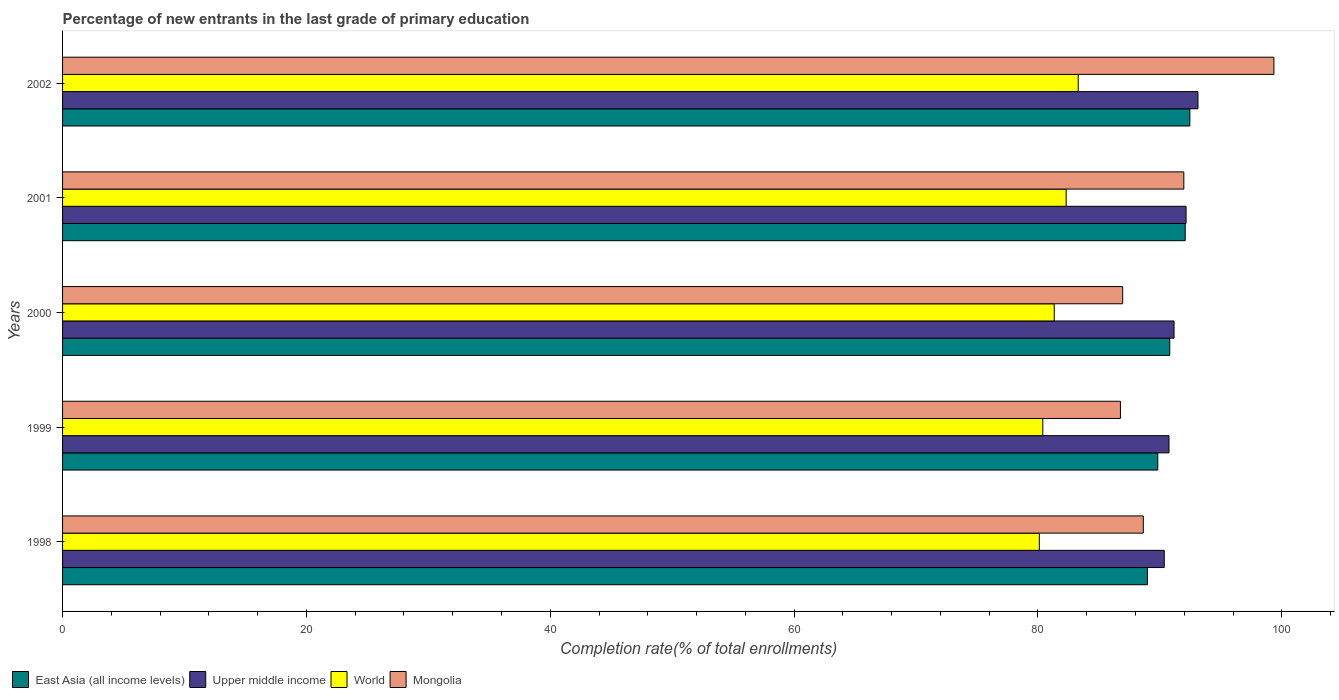How many different coloured bars are there?
Ensure brevity in your answer.  4. How many groups of bars are there?
Make the answer very short. 5. Are the number of bars on each tick of the Y-axis equal?
Your response must be concise. Yes. How many bars are there on the 4th tick from the bottom?
Your answer should be compact. 4. What is the percentage of new entrants in East Asia (all income levels) in 2000?
Provide a short and direct response. 90.81. Across all years, what is the maximum percentage of new entrants in World?
Offer a very short reply. 83.3. Across all years, what is the minimum percentage of new entrants in Mongolia?
Offer a very short reply. 86.76. What is the total percentage of new entrants in East Asia (all income levels) in the graph?
Offer a very short reply. 454.14. What is the difference between the percentage of new entrants in East Asia (all income levels) in 1998 and that in 2000?
Your response must be concise. -1.83. What is the difference between the percentage of new entrants in East Asia (all income levels) in 1998 and the percentage of new entrants in World in 2001?
Provide a succinct answer. 6.66. What is the average percentage of new entrants in Upper middle income per year?
Offer a terse response. 91.5. In the year 2001, what is the difference between the percentage of new entrants in Mongolia and percentage of new entrants in World?
Keep it short and to the point. 9.65. What is the ratio of the percentage of new entrants in Upper middle income in 1998 to that in 2001?
Provide a succinct answer. 0.98. Is the percentage of new entrants in World in 1998 less than that in 1999?
Offer a terse response. Yes. Is the difference between the percentage of new entrants in Mongolia in 2001 and 2002 greater than the difference between the percentage of new entrants in World in 2001 and 2002?
Your answer should be compact. No. What is the difference between the highest and the second highest percentage of new entrants in Mongolia?
Offer a terse response. 7.39. What is the difference between the highest and the lowest percentage of new entrants in East Asia (all income levels)?
Give a very brief answer. 3.48. In how many years, is the percentage of new entrants in Upper middle income greater than the average percentage of new entrants in Upper middle income taken over all years?
Provide a succinct answer. 2. Is the sum of the percentage of new entrants in East Asia (all income levels) in 2001 and 2002 greater than the maximum percentage of new entrants in Mongolia across all years?
Your answer should be compact. Yes. What does the 1st bar from the top in 2000 represents?
Make the answer very short. Mongolia. What does the 1st bar from the bottom in 1998 represents?
Offer a very short reply. East Asia (all income levels). Is it the case that in every year, the sum of the percentage of new entrants in Mongolia and percentage of new entrants in East Asia (all income levels) is greater than the percentage of new entrants in Upper middle income?
Offer a terse response. Yes. How many bars are there?
Keep it short and to the point. 20. How many years are there in the graph?
Make the answer very short. 5. What is the difference between two consecutive major ticks on the X-axis?
Give a very brief answer. 20. Does the graph contain any zero values?
Ensure brevity in your answer.  No. Does the graph contain grids?
Your answer should be compact. No. How are the legend labels stacked?
Offer a very short reply. Horizontal. What is the title of the graph?
Make the answer very short. Percentage of new entrants in the last grade of primary education. What is the label or title of the X-axis?
Offer a very short reply. Completion rate(% of total enrollments). What is the Completion rate(% of total enrollments) in East Asia (all income levels) in 1998?
Provide a succinct answer. 88.97. What is the Completion rate(% of total enrollments) of Upper middle income in 1998?
Provide a succinct answer. 90.36. What is the Completion rate(% of total enrollments) in World in 1998?
Provide a short and direct response. 80.11. What is the Completion rate(% of total enrollments) of Mongolia in 1998?
Offer a terse response. 88.64. What is the Completion rate(% of total enrollments) of East Asia (all income levels) in 1999?
Make the answer very short. 89.83. What is the Completion rate(% of total enrollments) of Upper middle income in 1999?
Make the answer very short. 90.74. What is the Completion rate(% of total enrollments) of World in 1999?
Provide a succinct answer. 80.39. What is the Completion rate(% of total enrollments) of Mongolia in 1999?
Keep it short and to the point. 86.76. What is the Completion rate(% of total enrollments) in East Asia (all income levels) in 2000?
Make the answer very short. 90.81. What is the Completion rate(% of total enrollments) of Upper middle income in 2000?
Your answer should be compact. 91.16. What is the Completion rate(% of total enrollments) of World in 2000?
Your answer should be compact. 81.33. What is the Completion rate(% of total enrollments) of Mongolia in 2000?
Give a very brief answer. 86.95. What is the Completion rate(% of total enrollments) in East Asia (all income levels) in 2001?
Your response must be concise. 92.08. What is the Completion rate(% of total enrollments) of Upper middle income in 2001?
Give a very brief answer. 92.14. What is the Completion rate(% of total enrollments) of World in 2001?
Provide a short and direct response. 82.31. What is the Completion rate(% of total enrollments) in Mongolia in 2001?
Your answer should be very brief. 91.96. What is the Completion rate(% of total enrollments) in East Asia (all income levels) in 2002?
Keep it short and to the point. 92.46. What is the Completion rate(% of total enrollments) of Upper middle income in 2002?
Your answer should be very brief. 93.12. What is the Completion rate(% of total enrollments) of World in 2002?
Keep it short and to the point. 83.3. What is the Completion rate(% of total enrollments) in Mongolia in 2002?
Offer a terse response. 99.35. Across all years, what is the maximum Completion rate(% of total enrollments) in East Asia (all income levels)?
Your answer should be very brief. 92.46. Across all years, what is the maximum Completion rate(% of total enrollments) in Upper middle income?
Offer a very short reply. 93.12. Across all years, what is the maximum Completion rate(% of total enrollments) of World?
Provide a short and direct response. 83.3. Across all years, what is the maximum Completion rate(% of total enrollments) of Mongolia?
Offer a very short reply. 99.35. Across all years, what is the minimum Completion rate(% of total enrollments) of East Asia (all income levels)?
Make the answer very short. 88.97. Across all years, what is the minimum Completion rate(% of total enrollments) of Upper middle income?
Give a very brief answer. 90.36. Across all years, what is the minimum Completion rate(% of total enrollments) in World?
Give a very brief answer. 80.11. Across all years, what is the minimum Completion rate(% of total enrollments) in Mongolia?
Keep it short and to the point. 86.76. What is the total Completion rate(% of total enrollments) in East Asia (all income levels) in the graph?
Offer a very short reply. 454.14. What is the total Completion rate(% of total enrollments) of Upper middle income in the graph?
Offer a very short reply. 457.52. What is the total Completion rate(% of total enrollments) of World in the graph?
Your response must be concise. 407.44. What is the total Completion rate(% of total enrollments) in Mongolia in the graph?
Your response must be concise. 453.66. What is the difference between the Completion rate(% of total enrollments) of East Asia (all income levels) in 1998 and that in 1999?
Your answer should be very brief. -0.85. What is the difference between the Completion rate(% of total enrollments) in Upper middle income in 1998 and that in 1999?
Give a very brief answer. -0.39. What is the difference between the Completion rate(% of total enrollments) in World in 1998 and that in 1999?
Keep it short and to the point. -0.28. What is the difference between the Completion rate(% of total enrollments) in Mongolia in 1998 and that in 1999?
Your answer should be very brief. 1.88. What is the difference between the Completion rate(% of total enrollments) of East Asia (all income levels) in 1998 and that in 2000?
Ensure brevity in your answer.  -1.83. What is the difference between the Completion rate(% of total enrollments) in Upper middle income in 1998 and that in 2000?
Offer a terse response. -0.8. What is the difference between the Completion rate(% of total enrollments) of World in 1998 and that in 2000?
Ensure brevity in your answer.  -1.22. What is the difference between the Completion rate(% of total enrollments) of Mongolia in 1998 and that in 2000?
Give a very brief answer. 1.69. What is the difference between the Completion rate(% of total enrollments) of East Asia (all income levels) in 1998 and that in 2001?
Ensure brevity in your answer.  -3.1. What is the difference between the Completion rate(% of total enrollments) in Upper middle income in 1998 and that in 2001?
Make the answer very short. -1.79. What is the difference between the Completion rate(% of total enrollments) of World in 1998 and that in 2001?
Your response must be concise. -2.2. What is the difference between the Completion rate(% of total enrollments) in Mongolia in 1998 and that in 2001?
Ensure brevity in your answer.  -3.32. What is the difference between the Completion rate(% of total enrollments) of East Asia (all income levels) in 1998 and that in 2002?
Your answer should be compact. -3.48. What is the difference between the Completion rate(% of total enrollments) in Upper middle income in 1998 and that in 2002?
Your answer should be compact. -2.76. What is the difference between the Completion rate(% of total enrollments) in World in 1998 and that in 2002?
Make the answer very short. -3.19. What is the difference between the Completion rate(% of total enrollments) of Mongolia in 1998 and that in 2002?
Offer a very short reply. -10.71. What is the difference between the Completion rate(% of total enrollments) of East Asia (all income levels) in 1999 and that in 2000?
Keep it short and to the point. -0.98. What is the difference between the Completion rate(% of total enrollments) in Upper middle income in 1999 and that in 2000?
Offer a very short reply. -0.41. What is the difference between the Completion rate(% of total enrollments) in World in 1999 and that in 2000?
Keep it short and to the point. -0.94. What is the difference between the Completion rate(% of total enrollments) of Mongolia in 1999 and that in 2000?
Your response must be concise. -0.19. What is the difference between the Completion rate(% of total enrollments) of East Asia (all income levels) in 1999 and that in 2001?
Provide a succinct answer. -2.25. What is the difference between the Completion rate(% of total enrollments) in Upper middle income in 1999 and that in 2001?
Make the answer very short. -1.4. What is the difference between the Completion rate(% of total enrollments) in World in 1999 and that in 2001?
Make the answer very short. -1.92. What is the difference between the Completion rate(% of total enrollments) of Mongolia in 1999 and that in 2001?
Your response must be concise. -5.2. What is the difference between the Completion rate(% of total enrollments) of East Asia (all income levels) in 1999 and that in 2002?
Your answer should be very brief. -2.63. What is the difference between the Completion rate(% of total enrollments) of Upper middle income in 1999 and that in 2002?
Provide a short and direct response. -2.38. What is the difference between the Completion rate(% of total enrollments) of World in 1999 and that in 2002?
Your answer should be compact. -2.9. What is the difference between the Completion rate(% of total enrollments) in Mongolia in 1999 and that in 2002?
Your answer should be very brief. -12.59. What is the difference between the Completion rate(% of total enrollments) in East Asia (all income levels) in 2000 and that in 2001?
Make the answer very short. -1.27. What is the difference between the Completion rate(% of total enrollments) in Upper middle income in 2000 and that in 2001?
Your answer should be very brief. -0.98. What is the difference between the Completion rate(% of total enrollments) of World in 2000 and that in 2001?
Your response must be concise. -0.98. What is the difference between the Completion rate(% of total enrollments) of Mongolia in 2000 and that in 2001?
Your answer should be very brief. -5.01. What is the difference between the Completion rate(% of total enrollments) in East Asia (all income levels) in 2000 and that in 2002?
Ensure brevity in your answer.  -1.65. What is the difference between the Completion rate(% of total enrollments) of Upper middle income in 2000 and that in 2002?
Provide a succinct answer. -1.96. What is the difference between the Completion rate(% of total enrollments) in World in 2000 and that in 2002?
Make the answer very short. -1.97. What is the difference between the Completion rate(% of total enrollments) in Mongolia in 2000 and that in 2002?
Give a very brief answer. -12.4. What is the difference between the Completion rate(% of total enrollments) of East Asia (all income levels) in 2001 and that in 2002?
Your answer should be very brief. -0.38. What is the difference between the Completion rate(% of total enrollments) in Upper middle income in 2001 and that in 2002?
Give a very brief answer. -0.98. What is the difference between the Completion rate(% of total enrollments) in World in 2001 and that in 2002?
Your answer should be very brief. -0.99. What is the difference between the Completion rate(% of total enrollments) of Mongolia in 2001 and that in 2002?
Your answer should be compact. -7.39. What is the difference between the Completion rate(% of total enrollments) of East Asia (all income levels) in 1998 and the Completion rate(% of total enrollments) of Upper middle income in 1999?
Ensure brevity in your answer.  -1.77. What is the difference between the Completion rate(% of total enrollments) of East Asia (all income levels) in 1998 and the Completion rate(% of total enrollments) of World in 1999?
Give a very brief answer. 8.58. What is the difference between the Completion rate(% of total enrollments) of East Asia (all income levels) in 1998 and the Completion rate(% of total enrollments) of Mongolia in 1999?
Provide a succinct answer. 2.21. What is the difference between the Completion rate(% of total enrollments) in Upper middle income in 1998 and the Completion rate(% of total enrollments) in World in 1999?
Provide a short and direct response. 9.96. What is the difference between the Completion rate(% of total enrollments) in Upper middle income in 1998 and the Completion rate(% of total enrollments) in Mongolia in 1999?
Your answer should be compact. 3.59. What is the difference between the Completion rate(% of total enrollments) in World in 1998 and the Completion rate(% of total enrollments) in Mongolia in 1999?
Provide a succinct answer. -6.65. What is the difference between the Completion rate(% of total enrollments) of East Asia (all income levels) in 1998 and the Completion rate(% of total enrollments) of Upper middle income in 2000?
Give a very brief answer. -2.18. What is the difference between the Completion rate(% of total enrollments) in East Asia (all income levels) in 1998 and the Completion rate(% of total enrollments) in World in 2000?
Offer a terse response. 7.64. What is the difference between the Completion rate(% of total enrollments) in East Asia (all income levels) in 1998 and the Completion rate(% of total enrollments) in Mongolia in 2000?
Offer a very short reply. 2.03. What is the difference between the Completion rate(% of total enrollments) in Upper middle income in 1998 and the Completion rate(% of total enrollments) in World in 2000?
Your answer should be very brief. 9.02. What is the difference between the Completion rate(% of total enrollments) in Upper middle income in 1998 and the Completion rate(% of total enrollments) in Mongolia in 2000?
Provide a short and direct response. 3.41. What is the difference between the Completion rate(% of total enrollments) in World in 1998 and the Completion rate(% of total enrollments) in Mongolia in 2000?
Offer a terse response. -6.84. What is the difference between the Completion rate(% of total enrollments) of East Asia (all income levels) in 1998 and the Completion rate(% of total enrollments) of Upper middle income in 2001?
Provide a short and direct response. -3.17. What is the difference between the Completion rate(% of total enrollments) in East Asia (all income levels) in 1998 and the Completion rate(% of total enrollments) in World in 2001?
Provide a succinct answer. 6.66. What is the difference between the Completion rate(% of total enrollments) in East Asia (all income levels) in 1998 and the Completion rate(% of total enrollments) in Mongolia in 2001?
Offer a terse response. -2.99. What is the difference between the Completion rate(% of total enrollments) in Upper middle income in 1998 and the Completion rate(% of total enrollments) in World in 2001?
Your response must be concise. 8.05. What is the difference between the Completion rate(% of total enrollments) in Upper middle income in 1998 and the Completion rate(% of total enrollments) in Mongolia in 2001?
Your answer should be very brief. -1.61. What is the difference between the Completion rate(% of total enrollments) of World in 1998 and the Completion rate(% of total enrollments) of Mongolia in 2001?
Make the answer very short. -11.85. What is the difference between the Completion rate(% of total enrollments) in East Asia (all income levels) in 1998 and the Completion rate(% of total enrollments) in Upper middle income in 2002?
Ensure brevity in your answer.  -4.15. What is the difference between the Completion rate(% of total enrollments) of East Asia (all income levels) in 1998 and the Completion rate(% of total enrollments) of World in 2002?
Provide a short and direct response. 5.68. What is the difference between the Completion rate(% of total enrollments) in East Asia (all income levels) in 1998 and the Completion rate(% of total enrollments) in Mongolia in 2002?
Your response must be concise. -10.38. What is the difference between the Completion rate(% of total enrollments) of Upper middle income in 1998 and the Completion rate(% of total enrollments) of World in 2002?
Provide a succinct answer. 7.06. What is the difference between the Completion rate(% of total enrollments) in Upper middle income in 1998 and the Completion rate(% of total enrollments) in Mongolia in 2002?
Offer a terse response. -9. What is the difference between the Completion rate(% of total enrollments) of World in 1998 and the Completion rate(% of total enrollments) of Mongolia in 2002?
Provide a succinct answer. -19.24. What is the difference between the Completion rate(% of total enrollments) of East Asia (all income levels) in 1999 and the Completion rate(% of total enrollments) of Upper middle income in 2000?
Provide a succinct answer. -1.33. What is the difference between the Completion rate(% of total enrollments) of East Asia (all income levels) in 1999 and the Completion rate(% of total enrollments) of World in 2000?
Your answer should be compact. 8.49. What is the difference between the Completion rate(% of total enrollments) of East Asia (all income levels) in 1999 and the Completion rate(% of total enrollments) of Mongolia in 2000?
Ensure brevity in your answer.  2.88. What is the difference between the Completion rate(% of total enrollments) in Upper middle income in 1999 and the Completion rate(% of total enrollments) in World in 2000?
Your answer should be compact. 9.41. What is the difference between the Completion rate(% of total enrollments) of Upper middle income in 1999 and the Completion rate(% of total enrollments) of Mongolia in 2000?
Provide a succinct answer. 3.8. What is the difference between the Completion rate(% of total enrollments) of World in 1999 and the Completion rate(% of total enrollments) of Mongolia in 2000?
Provide a succinct answer. -6.55. What is the difference between the Completion rate(% of total enrollments) of East Asia (all income levels) in 1999 and the Completion rate(% of total enrollments) of Upper middle income in 2001?
Your answer should be very brief. -2.32. What is the difference between the Completion rate(% of total enrollments) of East Asia (all income levels) in 1999 and the Completion rate(% of total enrollments) of World in 2001?
Your response must be concise. 7.52. What is the difference between the Completion rate(% of total enrollments) in East Asia (all income levels) in 1999 and the Completion rate(% of total enrollments) in Mongolia in 2001?
Offer a terse response. -2.14. What is the difference between the Completion rate(% of total enrollments) of Upper middle income in 1999 and the Completion rate(% of total enrollments) of World in 2001?
Your answer should be compact. 8.43. What is the difference between the Completion rate(% of total enrollments) in Upper middle income in 1999 and the Completion rate(% of total enrollments) in Mongolia in 2001?
Provide a succinct answer. -1.22. What is the difference between the Completion rate(% of total enrollments) of World in 1999 and the Completion rate(% of total enrollments) of Mongolia in 2001?
Your answer should be compact. -11.57. What is the difference between the Completion rate(% of total enrollments) in East Asia (all income levels) in 1999 and the Completion rate(% of total enrollments) in Upper middle income in 2002?
Ensure brevity in your answer.  -3.29. What is the difference between the Completion rate(% of total enrollments) of East Asia (all income levels) in 1999 and the Completion rate(% of total enrollments) of World in 2002?
Keep it short and to the point. 6.53. What is the difference between the Completion rate(% of total enrollments) in East Asia (all income levels) in 1999 and the Completion rate(% of total enrollments) in Mongolia in 2002?
Give a very brief answer. -9.52. What is the difference between the Completion rate(% of total enrollments) of Upper middle income in 1999 and the Completion rate(% of total enrollments) of World in 2002?
Offer a terse response. 7.45. What is the difference between the Completion rate(% of total enrollments) in Upper middle income in 1999 and the Completion rate(% of total enrollments) in Mongolia in 2002?
Your answer should be compact. -8.61. What is the difference between the Completion rate(% of total enrollments) of World in 1999 and the Completion rate(% of total enrollments) of Mongolia in 2002?
Provide a succinct answer. -18.96. What is the difference between the Completion rate(% of total enrollments) of East Asia (all income levels) in 2000 and the Completion rate(% of total enrollments) of Upper middle income in 2001?
Offer a very short reply. -1.34. What is the difference between the Completion rate(% of total enrollments) in East Asia (all income levels) in 2000 and the Completion rate(% of total enrollments) in World in 2001?
Your answer should be very brief. 8.5. What is the difference between the Completion rate(% of total enrollments) of East Asia (all income levels) in 2000 and the Completion rate(% of total enrollments) of Mongolia in 2001?
Make the answer very short. -1.15. What is the difference between the Completion rate(% of total enrollments) of Upper middle income in 2000 and the Completion rate(% of total enrollments) of World in 2001?
Offer a very short reply. 8.85. What is the difference between the Completion rate(% of total enrollments) of Upper middle income in 2000 and the Completion rate(% of total enrollments) of Mongolia in 2001?
Provide a short and direct response. -0.8. What is the difference between the Completion rate(% of total enrollments) in World in 2000 and the Completion rate(% of total enrollments) in Mongolia in 2001?
Provide a short and direct response. -10.63. What is the difference between the Completion rate(% of total enrollments) of East Asia (all income levels) in 2000 and the Completion rate(% of total enrollments) of Upper middle income in 2002?
Keep it short and to the point. -2.31. What is the difference between the Completion rate(% of total enrollments) of East Asia (all income levels) in 2000 and the Completion rate(% of total enrollments) of World in 2002?
Your answer should be compact. 7.51. What is the difference between the Completion rate(% of total enrollments) in East Asia (all income levels) in 2000 and the Completion rate(% of total enrollments) in Mongolia in 2002?
Your answer should be very brief. -8.54. What is the difference between the Completion rate(% of total enrollments) of Upper middle income in 2000 and the Completion rate(% of total enrollments) of World in 2002?
Offer a very short reply. 7.86. What is the difference between the Completion rate(% of total enrollments) in Upper middle income in 2000 and the Completion rate(% of total enrollments) in Mongolia in 2002?
Give a very brief answer. -8.19. What is the difference between the Completion rate(% of total enrollments) in World in 2000 and the Completion rate(% of total enrollments) in Mongolia in 2002?
Make the answer very short. -18.02. What is the difference between the Completion rate(% of total enrollments) of East Asia (all income levels) in 2001 and the Completion rate(% of total enrollments) of Upper middle income in 2002?
Your response must be concise. -1.04. What is the difference between the Completion rate(% of total enrollments) of East Asia (all income levels) in 2001 and the Completion rate(% of total enrollments) of World in 2002?
Offer a very short reply. 8.78. What is the difference between the Completion rate(% of total enrollments) of East Asia (all income levels) in 2001 and the Completion rate(% of total enrollments) of Mongolia in 2002?
Make the answer very short. -7.27. What is the difference between the Completion rate(% of total enrollments) of Upper middle income in 2001 and the Completion rate(% of total enrollments) of World in 2002?
Keep it short and to the point. 8.84. What is the difference between the Completion rate(% of total enrollments) of Upper middle income in 2001 and the Completion rate(% of total enrollments) of Mongolia in 2002?
Ensure brevity in your answer.  -7.21. What is the difference between the Completion rate(% of total enrollments) in World in 2001 and the Completion rate(% of total enrollments) in Mongolia in 2002?
Provide a short and direct response. -17.04. What is the average Completion rate(% of total enrollments) of East Asia (all income levels) per year?
Provide a short and direct response. 90.83. What is the average Completion rate(% of total enrollments) of Upper middle income per year?
Provide a succinct answer. 91.5. What is the average Completion rate(% of total enrollments) in World per year?
Give a very brief answer. 81.49. What is the average Completion rate(% of total enrollments) of Mongolia per year?
Ensure brevity in your answer.  90.73. In the year 1998, what is the difference between the Completion rate(% of total enrollments) in East Asia (all income levels) and Completion rate(% of total enrollments) in Upper middle income?
Your response must be concise. -1.38. In the year 1998, what is the difference between the Completion rate(% of total enrollments) of East Asia (all income levels) and Completion rate(% of total enrollments) of World?
Your response must be concise. 8.86. In the year 1998, what is the difference between the Completion rate(% of total enrollments) of East Asia (all income levels) and Completion rate(% of total enrollments) of Mongolia?
Your response must be concise. 0.34. In the year 1998, what is the difference between the Completion rate(% of total enrollments) of Upper middle income and Completion rate(% of total enrollments) of World?
Ensure brevity in your answer.  10.25. In the year 1998, what is the difference between the Completion rate(% of total enrollments) in Upper middle income and Completion rate(% of total enrollments) in Mongolia?
Offer a terse response. 1.72. In the year 1998, what is the difference between the Completion rate(% of total enrollments) in World and Completion rate(% of total enrollments) in Mongolia?
Give a very brief answer. -8.53. In the year 1999, what is the difference between the Completion rate(% of total enrollments) in East Asia (all income levels) and Completion rate(% of total enrollments) in Upper middle income?
Ensure brevity in your answer.  -0.92. In the year 1999, what is the difference between the Completion rate(% of total enrollments) in East Asia (all income levels) and Completion rate(% of total enrollments) in World?
Provide a short and direct response. 9.43. In the year 1999, what is the difference between the Completion rate(% of total enrollments) in East Asia (all income levels) and Completion rate(% of total enrollments) in Mongolia?
Keep it short and to the point. 3.06. In the year 1999, what is the difference between the Completion rate(% of total enrollments) in Upper middle income and Completion rate(% of total enrollments) in World?
Your answer should be compact. 10.35. In the year 1999, what is the difference between the Completion rate(% of total enrollments) of Upper middle income and Completion rate(% of total enrollments) of Mongolia?
Your answer should be compact. 3.98. In the year 1999, what is the difference between the Completion rate(% of total enrollments) in World and Completion rate(% of total enrollments) in Mongolia?
Give a very brief answer. -6.37. In the year 2000, what is the difference between the Completion rate(% of total enrollments) of East Asia (all income levels) and Completion rate(% of total enrollments) of Upper middle income?
Give a very brief answer. -0.35. In the year 2000, what is the difference between the Completion rate(% of total enrollments) of East Asia (all income levels) and Completion rate(% of total enrollments) of World?
Provide a short and direct response. 9.47. In the year 2000, what is the difference between the Completion rate(% of total enrollments) in East Asia (all income levels) and Completion rate(% of total enrollments) in Mongolia?
Provide a short and direct response. 3.86. In the year 2000, what is the difference between the Completion rate(% of total enrollments) of Upper middle income and Completion rate(% of total enrollments) of World?
Your response must be concise. 9.83. In the year 2000, what is the difference between the Completion rate(% of total enrollments) in Upper middle income and Completion rate(% of total enrollments) in Mongolia?
Keep it short and to the point. 4.21. In the year 2000, what is the difference between the Completion rate(% of total enrollments) in World and Completion rate(% of total enrollments) in Mongolia?
Your response must be concise. -5.61. In the year 2001, what is the difference between the Completion rate(% of total enrollments) in East Asia (all income levels) and Completion rate(% of total enrollments) in Upper middle income?
Your response must be concise. -0.07. In the year 2001, what is the difference between the Completion rate(% of total enrollments) in East Asia (all income levels) and Completion rate(% of total enrollments) in World?
Provide a succinct answer. 9.77. In the year 2001, what is the difference between the Completion rate(% of total enrollments) of East Asia (all income levels) and Completion rate(% of total enrollments) of Mongolia?
Keep it short and to the point. 0.11. In the year 2001, what is the difference between the Completion rate(% of total enrollments) in Upper middle income and Completion rate(% of total enrollments) in World?
Make the answer very short. 9.83. In the year 2001, what is the difference between the Completion rate(% of total enrollments) in Upper middle income and Completion rate(% of total enrollments) in Mongolia?
Your answer should be very brief. 0.18. In the year 2001, what is the difference between the Completion rate(% of total enrollments) of World and Completion rate(% of total enrollments) of Mongolia?
Ensure brevity in your answer.  -9.65. In the year 2002, what is the difference between the Completion rate(% of total enrollments) of East Asia (all income levels) and Completion rate(% of total enrollments) of Upper middle income?
Your answer should be compact. -0.66. In the year 2002, what is the difference between the Completion rate(% of total enrollments) in East Asia (all income levels) and Completion rate(% of total enrollments) in World?
Offer a very short reply. 9.16. In the year 2002, what is the difference between the Completion rate(% of total enrollments) in East Asia (all income levels) and Completion rate(% of total enrollments) in Mongolia?
Offer a terse response. -6.89. In the year 2002, what is the difference between the Completion rate(% of total enrollments) in Upper middle income and Completion rate(% of total enrollments) in World?
Provide a succinct answer. 9.82. In the year 2002, what is the difference between the Completion rate(% of total enrollments) in Upper middle income and Completion rate(% of total enrollments) in Mongolia?
Keep it short and to the point. -6.23. In the year 2002, what is the difference between the Completion rate(% of total enrollments) of World and Completion rate(% of total enrollments) of Mongolia?
Ensure brevity in your answer.  -16.05. What is the ratio of the Completion rate(% of total enrollments) in World in 1998 to that in 1999?
Ensure brevity in your answer.  1. What is the ratio of the Completion rate(% of total enrollments) of Mongolia in 1998 to that in 1999?
Make the answer very short. 1.02. What is the ratio of the Completion rate(% of total enrollments) of East Asia (all income levels) in 1998 to that in 2000?
Provide a succinct answer. 0.98. What is the ratio of the Completion rate(% of total enrollments) in Upper middle income in 1998 to that in 2000?
Provide a short and direct response. 0.99. What is the ratio of the Completion rate(% of total enrollments) of Mongolia in 1998 to that in 2000?
Give a very brief answer. 1.02. What is the ratio of the Completion rate(% of total enrollments) in East Asia (all income levels) in 1998 to that in 2001?
Ensure brevity in your answer.  0.97. What is the ratio of the Completion rate(% of total enrollments) in Upper middle income in 1998 to that in 2001?
Give a very brief answer. 0.98. What is the ratio of the Completion rate(% of total enrollments) in World in 1998 to that in 2001?
Provide a short and direct response. 0.97. What is the ratio of the Completion rate(% of total enrollments) of Mongolia in 1998 to that in 2001?
Your response must be concise. 0.96. What is the ratio of the Completion rate(% of total enrollments) in East Asia (all income levels) in 1998 to that in 2002?
Offer a very short reply. 0.96. What is the ratio of the Completion rate(% of total enrollments) in Upper middle income in 1998 to that in 2002?
Your answer should be very brief. 0.97. What is the ratio of the Completion rate(% of total enrollments) of World in 1998 to that in 2002?
Keep it short and to the point. 0.96. What is the ratio of the Completion rate(% of total enrollments) in Mongolia in 1998 to that in 2002?
Make the answer very short. 0.89. What is the ratio of the Completion rate(% of total enrollments) of East Asia (all income levels) in 1999 to that in 2000?
Your answer should be very brief. 0.99. What is the ratio of the Completion rate(% of total enrollments) of Upper middle income in 1999 to that in 2000?
Offer a terse response. 1. What is the ratio of the Completion rate(% of total enrollments) in Mongolia in 1999 to that in 2000?
Your answer should be very brief. 1. What is the ratio of the Completion rate(% of total enrollments) in East Asia (all income levels) in 1999 to that in 2001?
Ensure brevity in your answer.  0.98. What is the ratio of the Completion rate(% of total enrollments) in World in 1999 to that in 2001?
Give a very brief answer. 0.98. What is the ratio of the Completion rate(% of total enrollments) of Mongolia in 1999 to that in 2001?
Your answer should be very brief. 0.94. What is the ratio of the Completion rate(% of total enrollments) of East Asia (all income levels) in 1999 to that in 2002?
Ensure brevity in your answer.  0.97. What is the ratio of the Completion rate(% of total enrollments) of Upper middle income in 1999 to that in 2002?
Offer a terse response. 0.97. What is the ratio of the Completion rate(% of total enrollments) in World in 1999 to that in 2002?
Keep it short and to the point. 0.97. What is the ratio of the Completion rate(% of total enrollments) in Mongolia in 1999 to that in 2002?
Give a very brief answer. 0.87. What is the ratio of the Completion rate(% of total enrollments) in East Asia (all income levels) in 2000 to that in 2001?
Your response must be concise. 0.99. What is the ratio of the Completion rate(% of total enrollments) of Upper middle income in 2000 to that in 2001?
Your answer should be compact. 0.99. What is the ratio of the Completion rate(% of total enrollments) in Mongolia in 2000 to that in 2001?
Your answer should be compact. 0.95. What is the ratio of the Completion rate(% of total enrollments) of East Asia (all income levels) in 2000 to that in 2002?
Your answer should be very brief. 0.98. What is the ratio of the Completion rate(% of total enrollments) of Upper middle income in 2000 to that in 2002?
Ensure brevity in your answer.  0.98. What is the ratio of the Completion rate(% of total enrollments) in World in 2000 to that in 2002?
Your answer should be very brief. 0.98. What is the ratio of the Completion rate(% of total enrollments) of Mongolia in 2000 to that in 2002?
Provide a succinct answer. 0.88. What is the ratio of the Completion rate(% of total enrollments) in East Asia (all income levels) in 2001 to that in 2002?
Your response must be concise. 1. What is the ratio of the Completion rate(% of total enrollments) in Upper middle income in 2001 to that in 2002?
Ensure brevity in your answer.  0.99. What is the ratio of the Completion rate(% of total enrollments) of World in 2001 to that in 2002?
Give a very brief answer. 0.99. What is the ratio of the Completion rate(% of total enrollments) of Mongolia in 2001 to that in 2002?
Provide a short and direct response. 0.93. What is the difference between the highest and the second highest Completion rate(% of total enrollments) of East Asia (all income levels)?
Your answer should be compact. 0.38. What is the difference between the highest and the second highest Completion rate(% of total enrollments) in Upper middle income?
Give a very brief answer. 0.98. What is the difference between the highest and the second highest Completion rate(% of total enrollments) of World?
Provide a succinct answer. 0.99. What is the difference between the highest and the second highest Completion rate(% of total enrollments) in Mongolia?
Offer a terse response. 7.39. What is the difference between the highest and the lowest Completion rate(% of total enrollments) of East Asia (all income levels)?
Offer a terse response. 3.48. What is the difference between the highest and the lowest Completion rate(% of total enrollments) of Upper middle income?
Make the answer very short. 2.76. What is the difference between the highest and the lowest Completion rate(% of total enrollments) of World?
Give a very brief answer. 3.19. What is the difference between the highest and the lowest Completion rate(% of total enrollments) in Mongolia?
Make the answer very short. 12.59. 